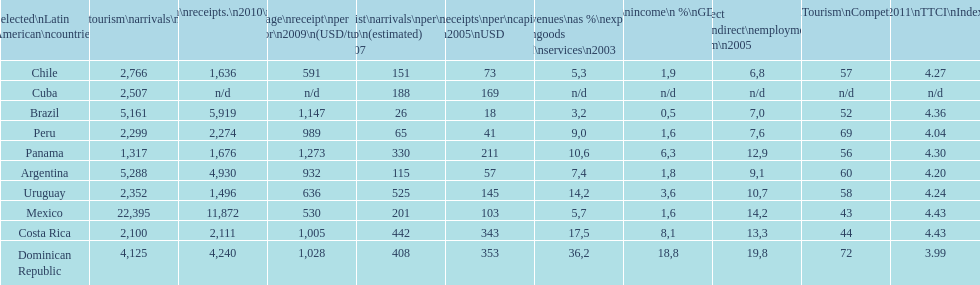How does brazil rank in average receipts per visitor in 2009? 1,147. 